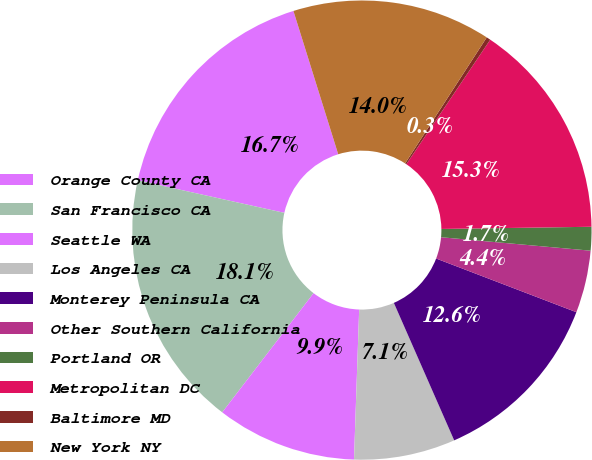<chart> <loc_0><loc_0><loc_500><loc_500><pie_chart><fcel>Orange County CA<fcel>San Francisco CA<fcel>Seattle WA<fcel>Los Angeles CA<fcel>Monterey Peninsula CA<fcel>Other Southern California<fcel>Portland OR<fcel>Metropolitan DC<fcel>Baltimore MD<fcel>New York NY<nl><fcel>16.7%<fcel>18.07%<fcel>9.86%<fcel>7.13%<fcel>12.6%<fcel>4.39%<fcel>1.66%<fcel>15.33%<fcel>0.29%<fcel>13.97%<nl></chart> 